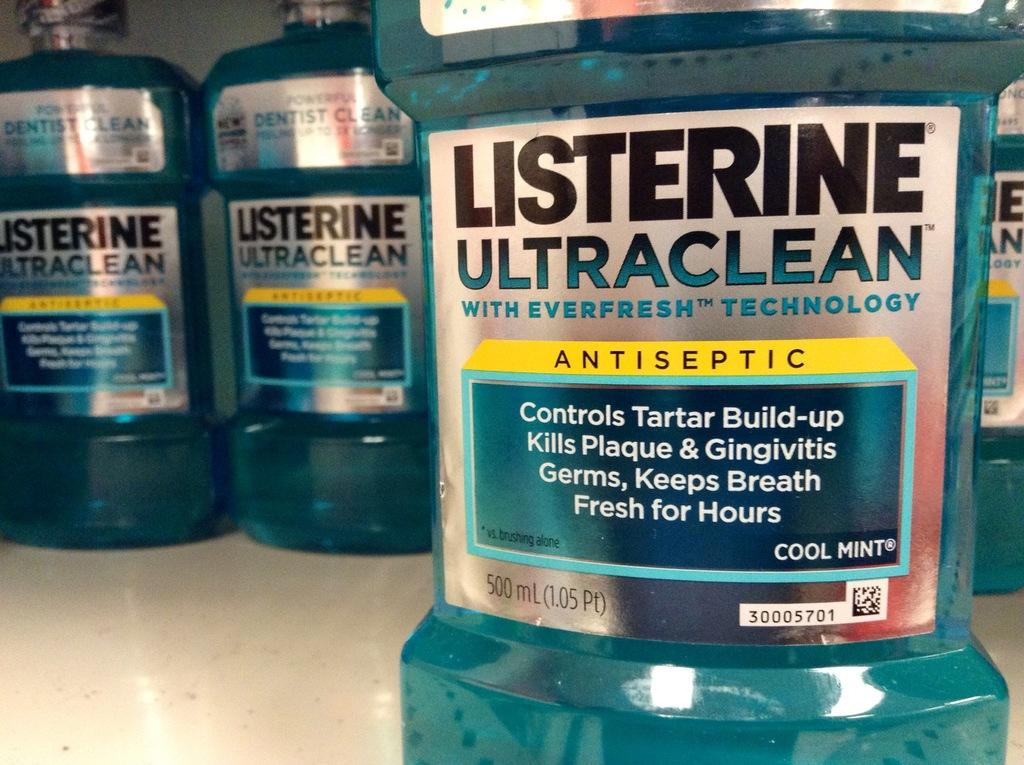<image>
Present a compact description of the photo's key features. Many bottles of cool mint flavored listerine mouthwash. 